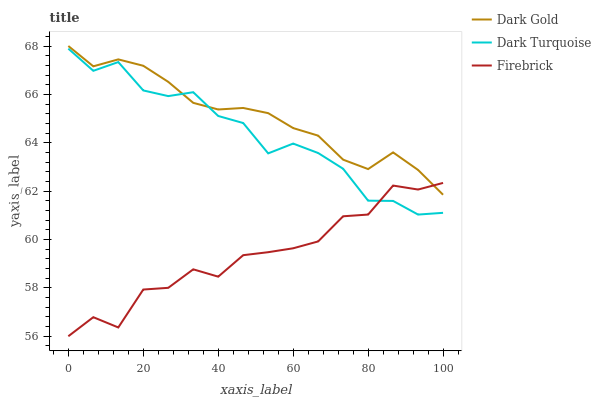Does Firebrick have the minimum area under the curve?
Answer yes or no. Yes. Does Dark Gold have the maximum area under the curve?
Answer yes or no. Yes. Does Dark Gold have the minimum area under the curve?
Answer yes or no. No. Does Firebrick have the maximum area under the curve?
Answer yes or no. No. Is Dark Gold the smoothest?
Answer yes or no. Yes. Is Firebrick the roughest?
Answer yes or no. Yes. Is Firebrick the smoothest?
Answer yes or no. No. Is Dark Gold the roughest?
Answer yes or no. No. Does Firebrick have the lowest value?
Answer yes or no. Yes. Does Dark Gold have the lowest value?
Answer yes or no. No. Does Dark Gold have the highest value?
Answer yes or no. Yes. Does Firebrick have the highest value?
Answer yes or no. No. Does Dark Gold intersect Dark Turquoise?
Answer yes or no. Yes. Is Dark Gold less than Dark Turquoise?
Answer yes or no. No. Is Dark Gold greater than Dark Turquoise?
Answer yes or no. No. 